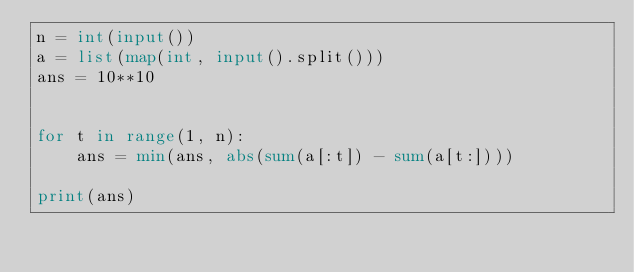Convert code to text. <code><loc_0><loc_0><loc_500><loc_500><_Python_>n = int(input())
a = list(map(int, input().split()))
ans = 10**10


for t in range(1, n):
	ans = min(ans, abs(sum(a[:t]) - sum(a[t:])))
	
print(ans)</code> 